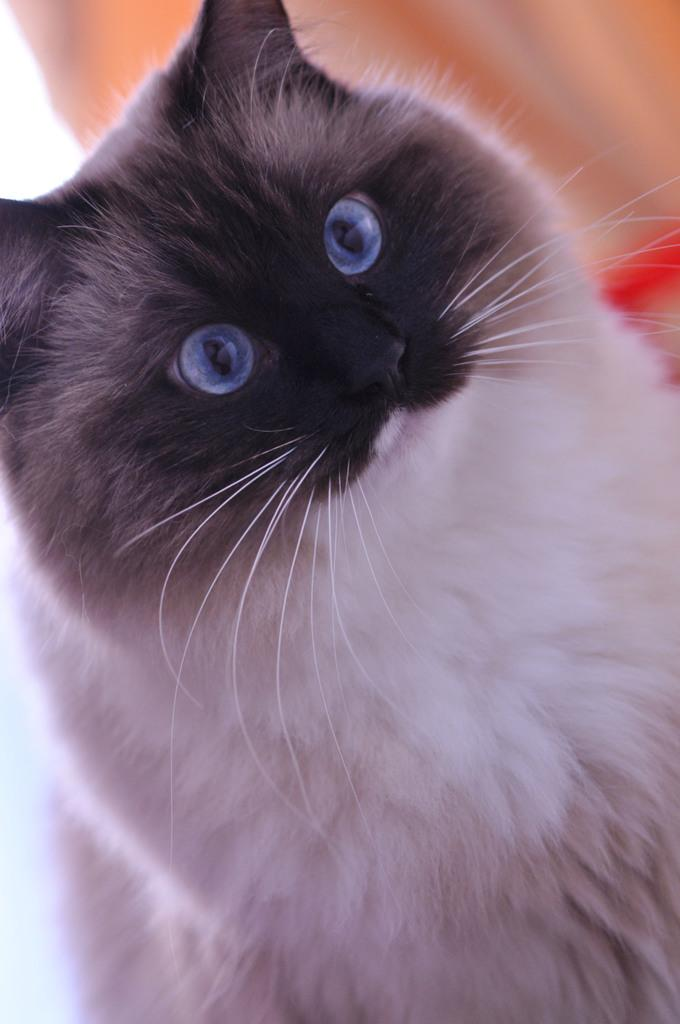What type of animal is in the image? There is a cat in the image. What color is the cat? The cat is in black and white color. What is unique about the cat's eyes? The cat has purple color eyes. Can you describe the background of the image? The background of the image is completely blurred. What type of stew is being prepared in the image? There is no stew present in the image; it features a cat with black and white color and purple eyes. Can you see a plane in the image? There is no plane visible in the image; it only shows a cat with a blurred background. 